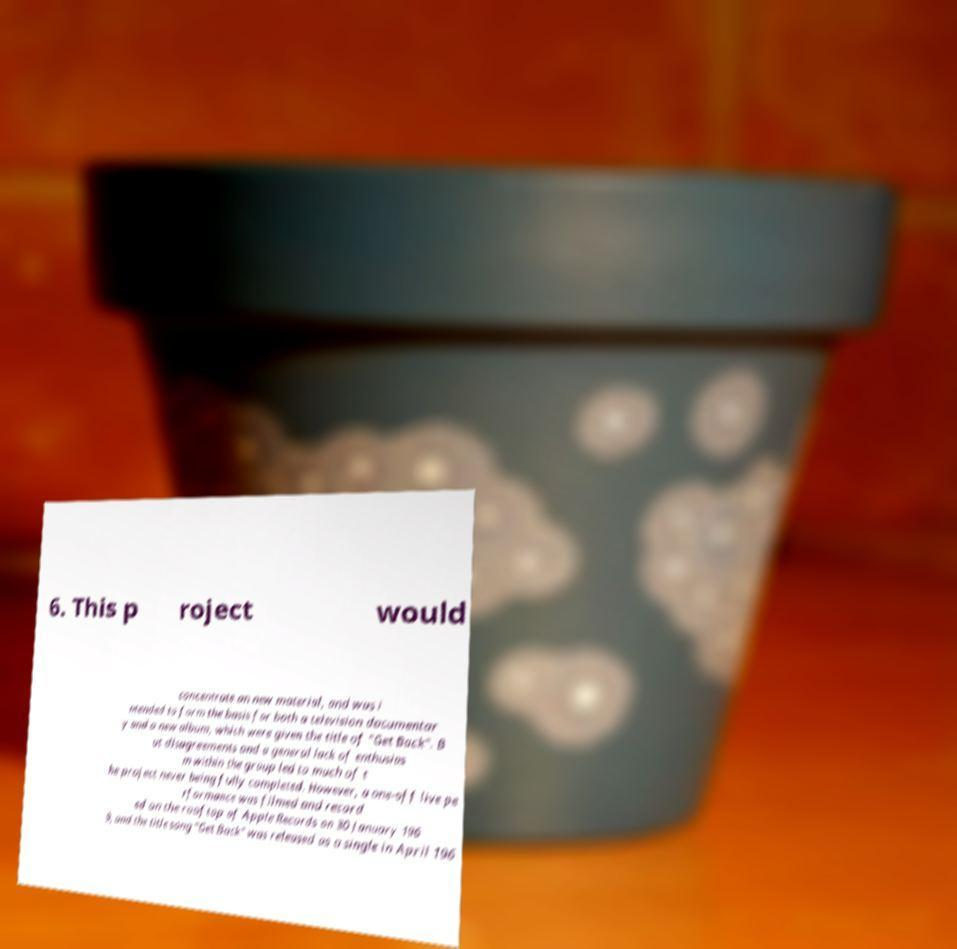Can you accurately transcribe the text from the provided image for me? 6. This p roject would concentrate on new material, and was i ntended to form the basis for both a television documentar y and a new album, which were given the title of "Get Back". B ut disagreements and a general lack of enthusias m within the group led to much of t he project never being fully completed. However, a one-off live pe rformance was filmed and record ed on the rooftop of Apple Records on 30 January 196 9, and the title song "Get Back" was released as a single in April 196 